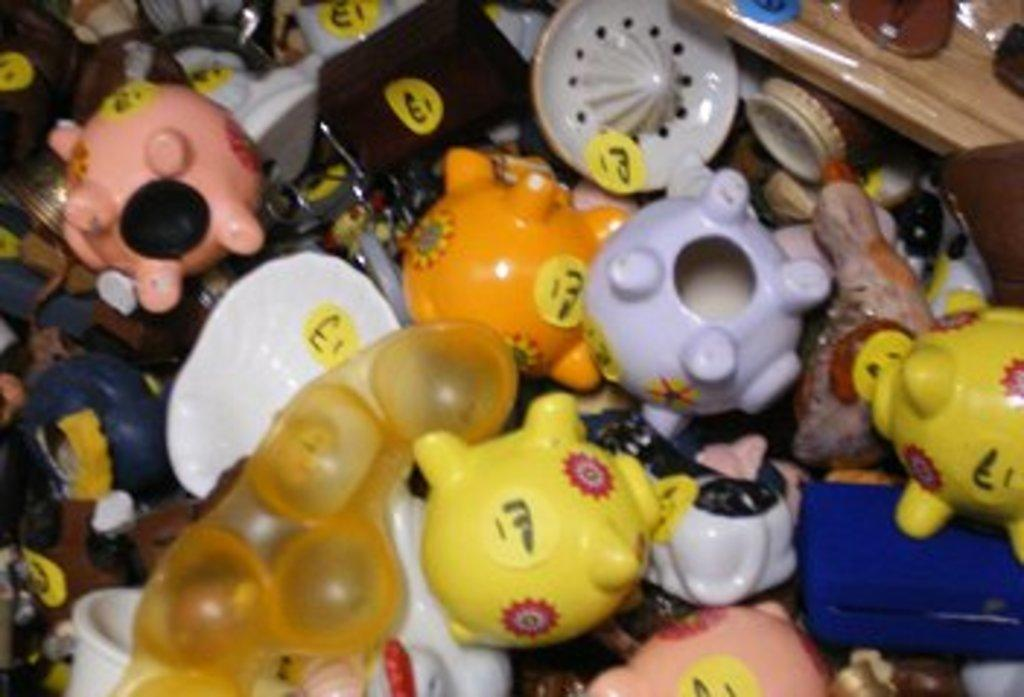What type of objects can be seen in the image? There are toys in the image. What historical event is depicted in the image involving oatmeal and pulling? There is no historical event, oatmeal, or pulling present in the image; it only features toys. 